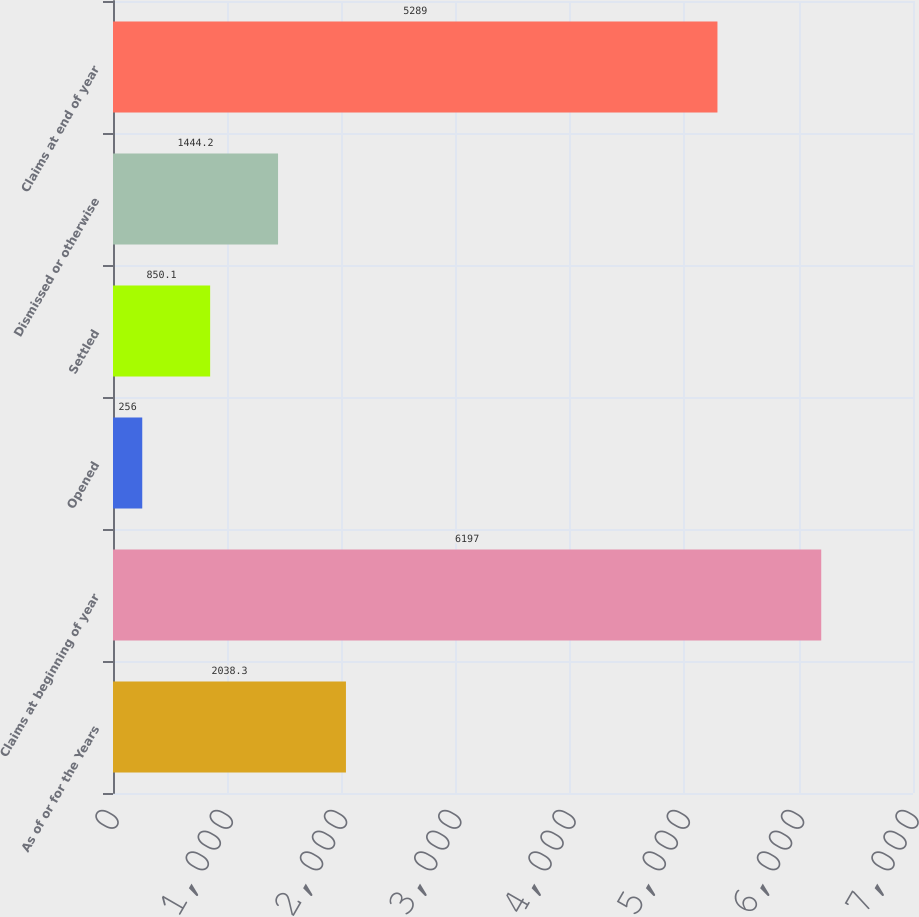Convert chart to OTSL. <chart><loc_0><loc_0><loc_500><loc_500><bar_chart><fcel>As of or for the Years<fcel>Claims at beginning of year<fcel>Opened<fcel>Settled<fcel>Dismissed or otherwise<fcel>Claims at end of year<nl><fcel>2038.3<fcel>6197<fcel>256<fcel>850.1<fcel>1444.2<fcel>5289<nl></chart> 